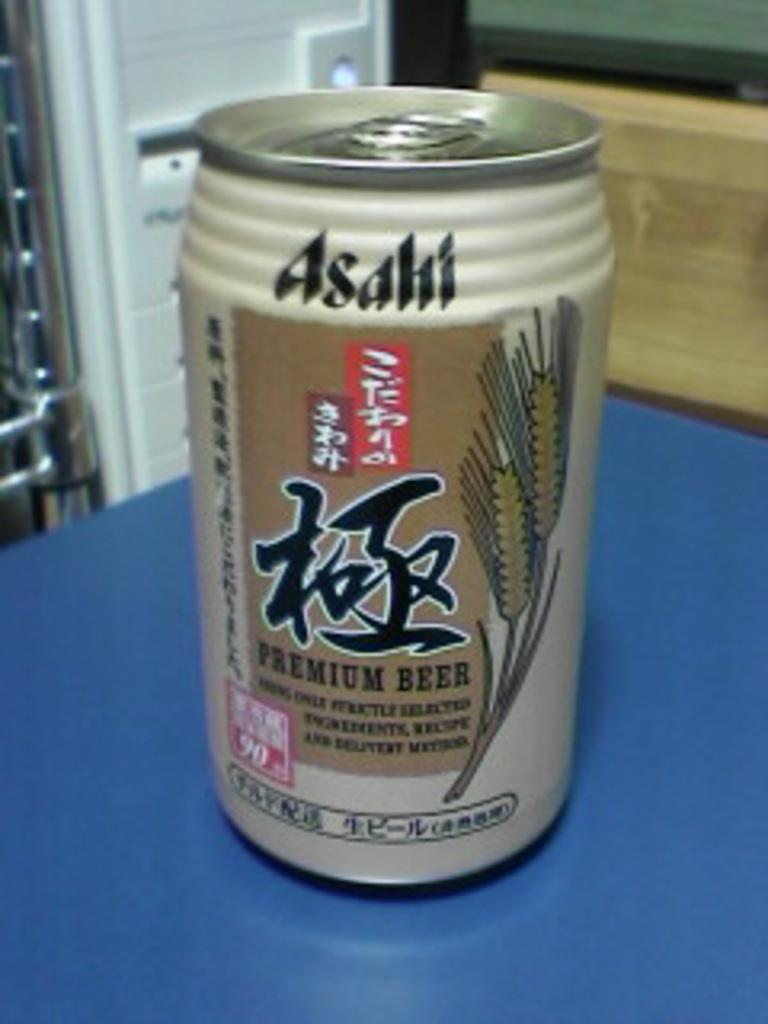<image>
Create a compact narrative representing the image presented. A can of Premium beer with Japanese characters on the can. 